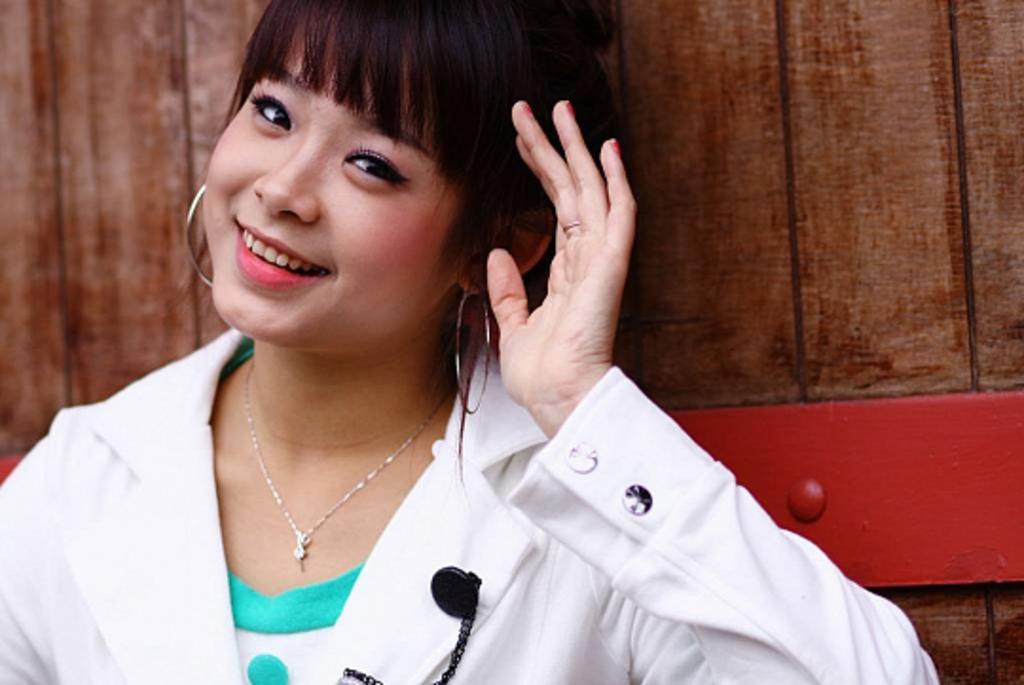Describe this image in one or two sentences. In the background we can see the wooden object. In this picture we can see a woman. She is giving a pose and smiling. 